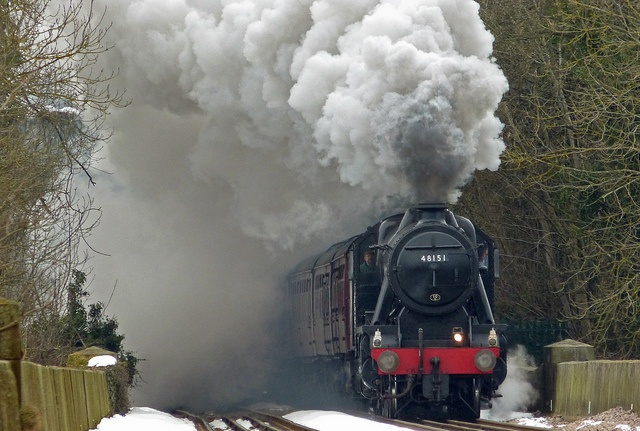Describe the objects in this image and their specific colors. I can see a train in darkgreen, black, gray, and darkblue tones in this image. 